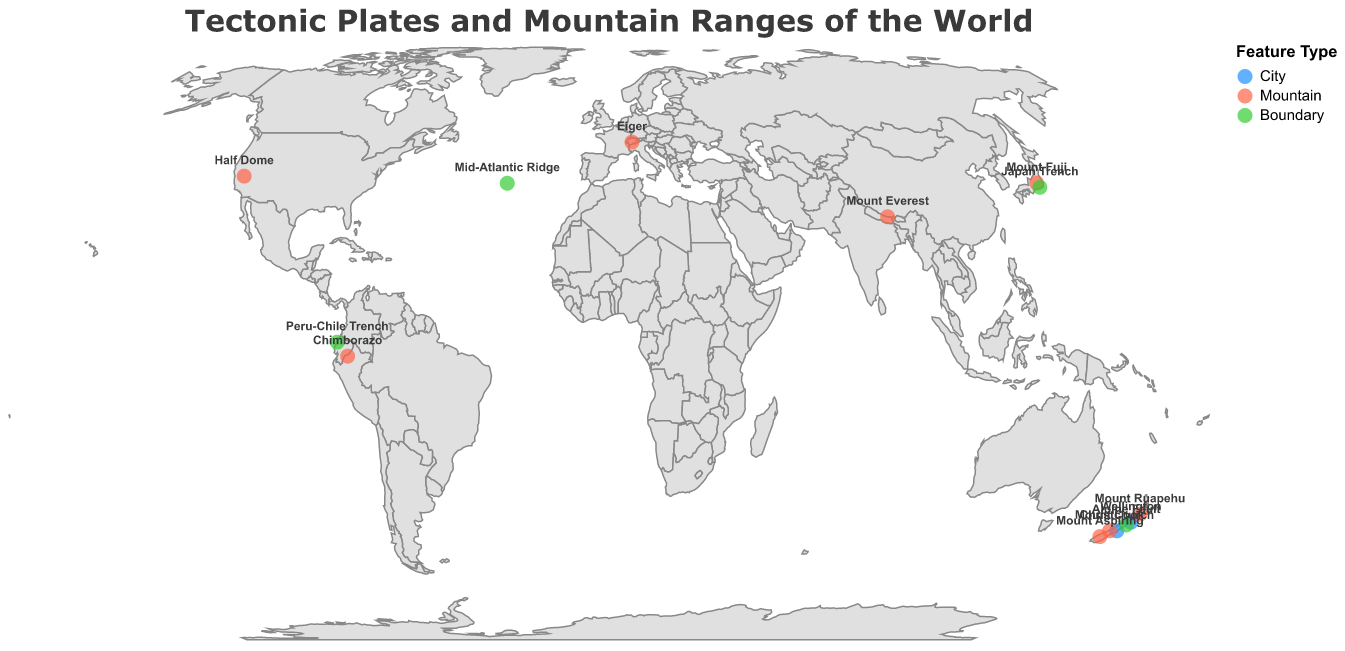What is the highest mountain shown on the map? The highest mountain on the map is Mount Everest with an elevation of 8848 meters.
Answer: Mount Everest Which tectonic plate boundary is associated with the highest mountain? Mount Everest is associated with the Indian-Eurasian plate boundary, as shown on the map.
Answer: Indian-Eurasian How many mountains in New Zealand are shown on the map? The map shows three mountains in New Zealand: Mount Aspiring, Mount Cook, and Mount Ruapehu.
Answer: Three What is the elevation difference between Mount Cook and Mount Ruapehu? Mount Cook has an elevation of 3724 meters and Mount Ruapehu has an elevation of 2797 meters. The difference is 3724 - 2797 = 927 meters.
Answer: 927 meters Which city lies along the Pacific-Australian plate boundary? Both Wellington and Christchurch lie along the Pacific-Australian plate boundary.
Answer: Wellington and Christchurch Identify a mountain that is part of the Pacific-Eurasian-Philippine plate boundary. Mount Fuji is the mountain that is part of the Pacific-Eurasian-Philippine plate boundary.
Answer: Mount Fuji How many plate boundaries are depicted on the map? The map depicts four plate boundaries: Alpine Fault, Japan Trench, Peru-Chile Trench, and Mid-Atlantic Ridge.
Answer: Four Which mountain has the highest elevation on the North American-Pacific plate boundary? Half Dome is the mountain on the North American-Pacific plate boundary with an elevation of 2695 meters.
Answer: Half Dome Compare the elevations of Mount Fuji and Eiger. Which one is higher? Mount Fuji has an elevation of 3776 meters, and Eiger has an elevation of 3967 meters. Eiger is higher.
Answer: Eiger Which tectonic plate boundary has a mountain and a trench associated with it? The Pacific-Eurasian-Philippine plate boundary has both Mount Fuji and the Japan Trench associated with it.
Answer: Pacific-Eurasian-Philippine 